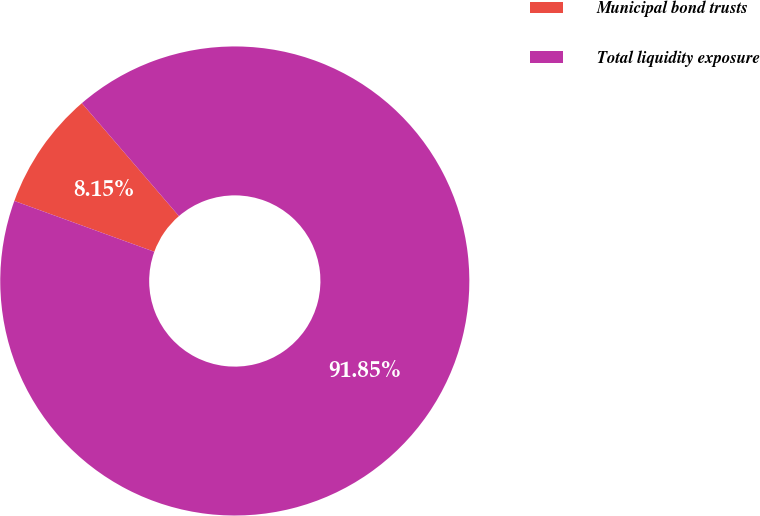Convert chart to OTSL. <chart><loc_0><loc_0><loc_500><loc_500><pie_chart><fcel>Municipal bond trusts<fcel>Total liquidity exposure<nl><fcel>8.15%<fcel>91.85%<nl></chart> 